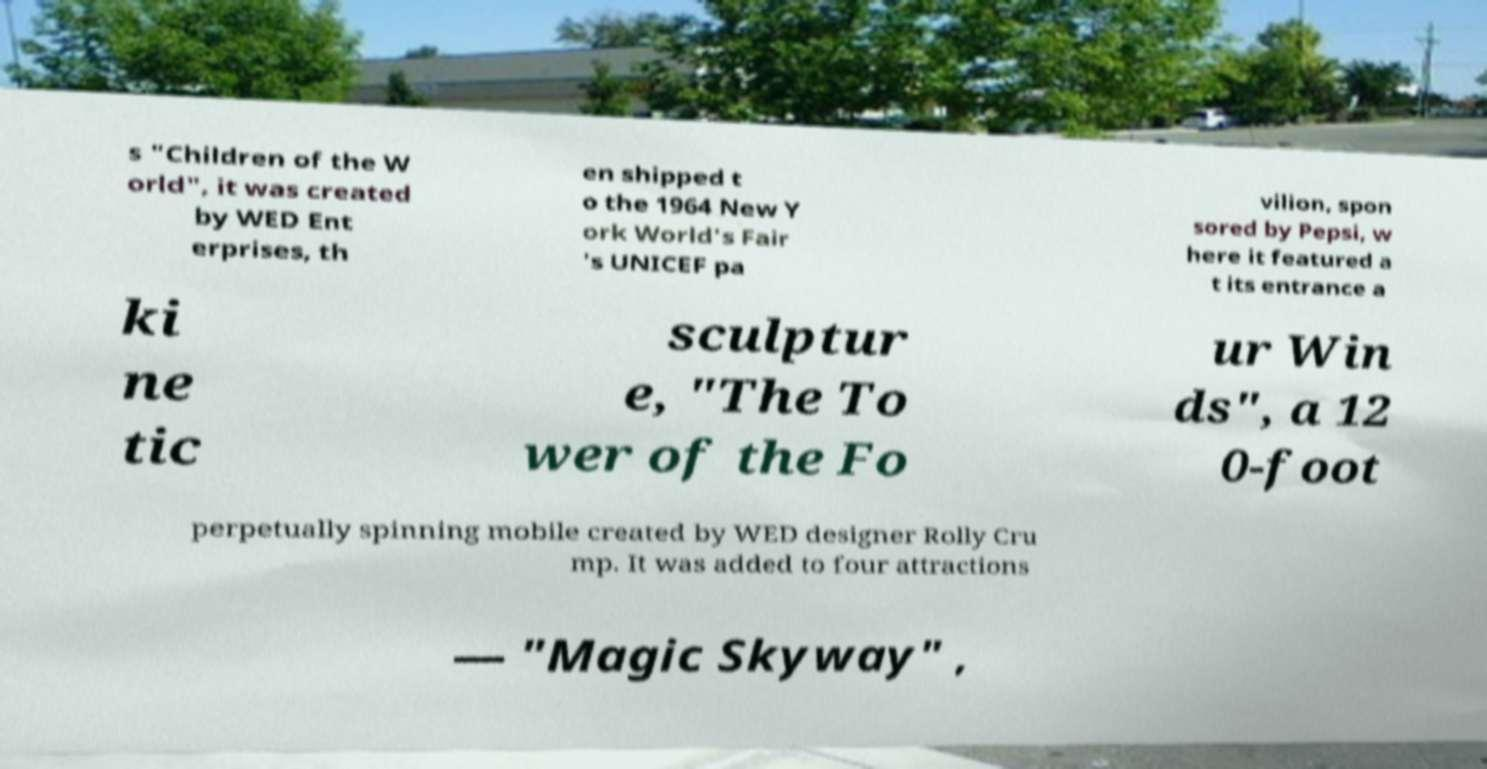For documentation purposes, I need the text within this image transcribed. Could you provide that? s "Children of the W orld", it was created by WED Ent erprises, th en shipped t o the 1964 New Y ork World's Fair 's UNICEF pa vilion, spon sored by Pepsi, w here it featured a t its entrance a ki ne tic sculptur e, "The To wer of the Fo ur Win ds", a 12 0-foot perpetually spinning mobile created by WED designer Rolly Cru mp. It was added to four attractions — "Magic Skyway" , 